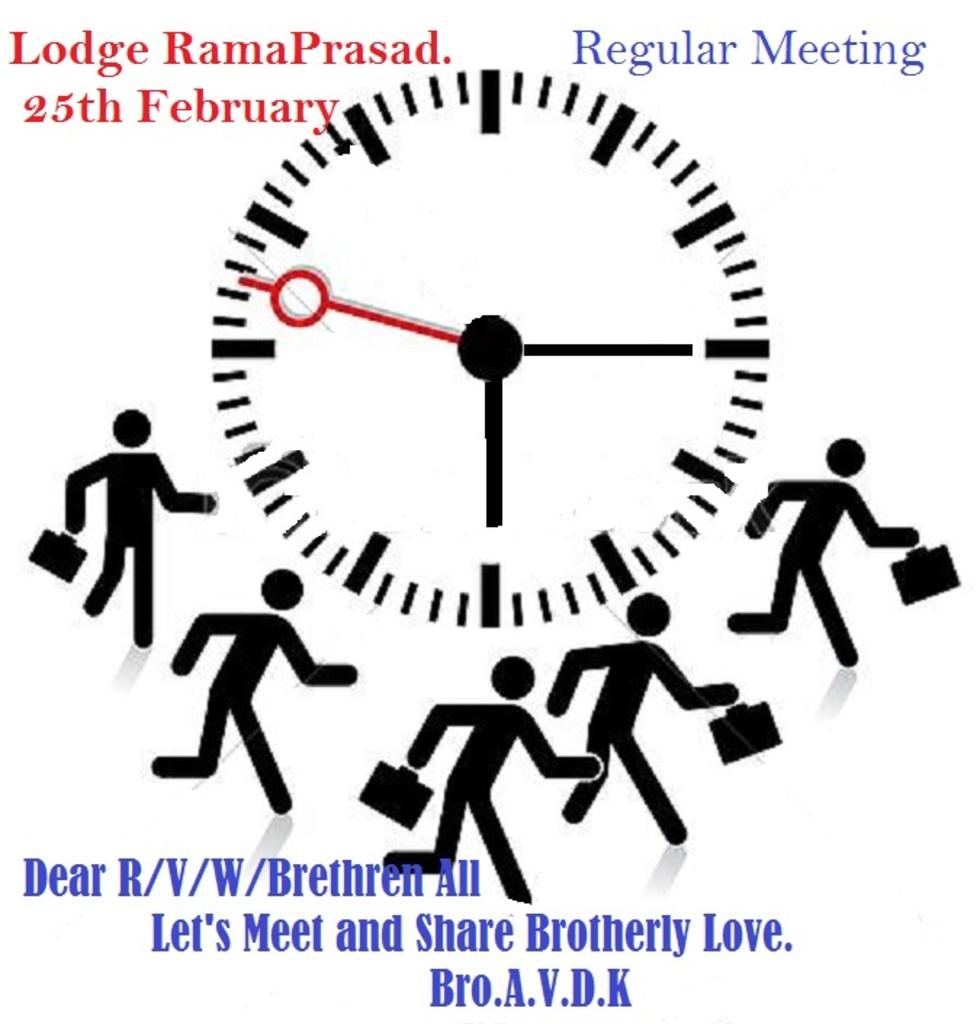<image>
Present a compact description of the photo's key features. A clock in the center of a page with stick figures running around it acts as a reminder for a Regular Meeting. 